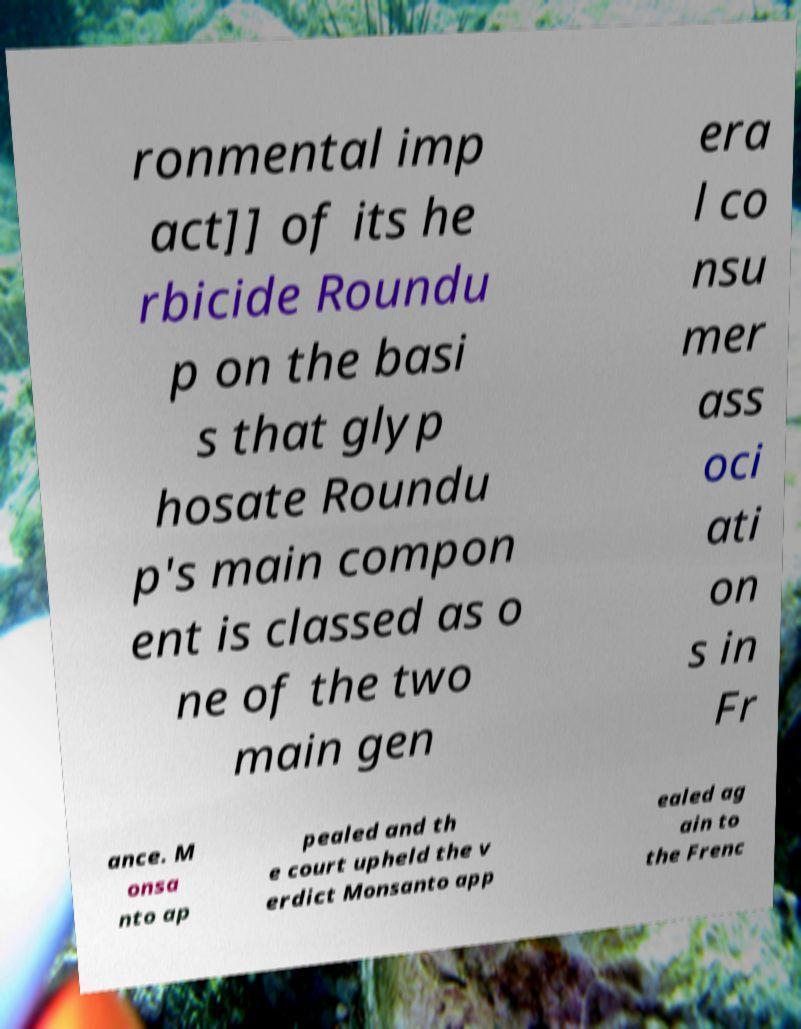Please identify and transcribe the text found in this image. ronmental imp act]] of its he rbicide Roundu p on the basi s that glyp hosate Roundu p's main compon ent is classed as o ne of the two main gen era l co nsu mer ass oci ati on s in Fr ance. M onsa nto ap pealed and th e court upheld the v erdict Monsanto app ealed ag ain to the Frenc 